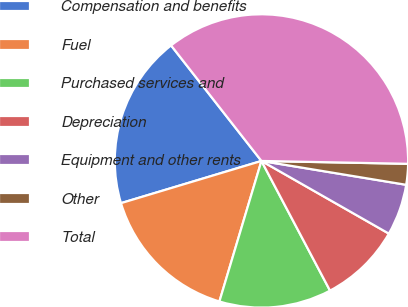Convert chart to OTSL. <chart><loc_0><loc_0><loc_500><loc_500><pie_chart><fcel>Compensation and benefits<fcel>Fuel<fcel>Purchased services and<fcel>Depreciation<fcel>Equipment and other rents<fcel>Other<fcel>Total<nl><fcel>19.08%<fcel>15.73%<fcel>12.37%<fcel>9.01%<fcel>5.65%<fcel>2.29%<fcel>35.88%<nl></chart> 